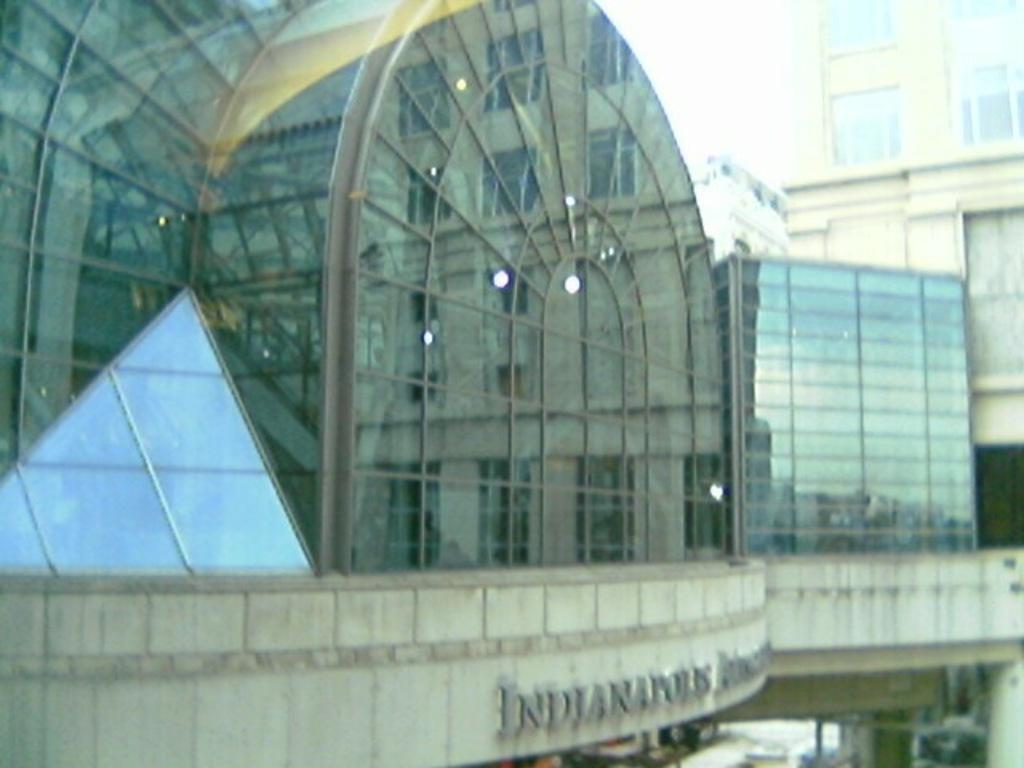What type of structures can be seen in the image? There are buildings in the image. What part of the natural environment is visible in the image? The sky is visible in the image. Where is the thread used in the image? There is no thread present in the image. 